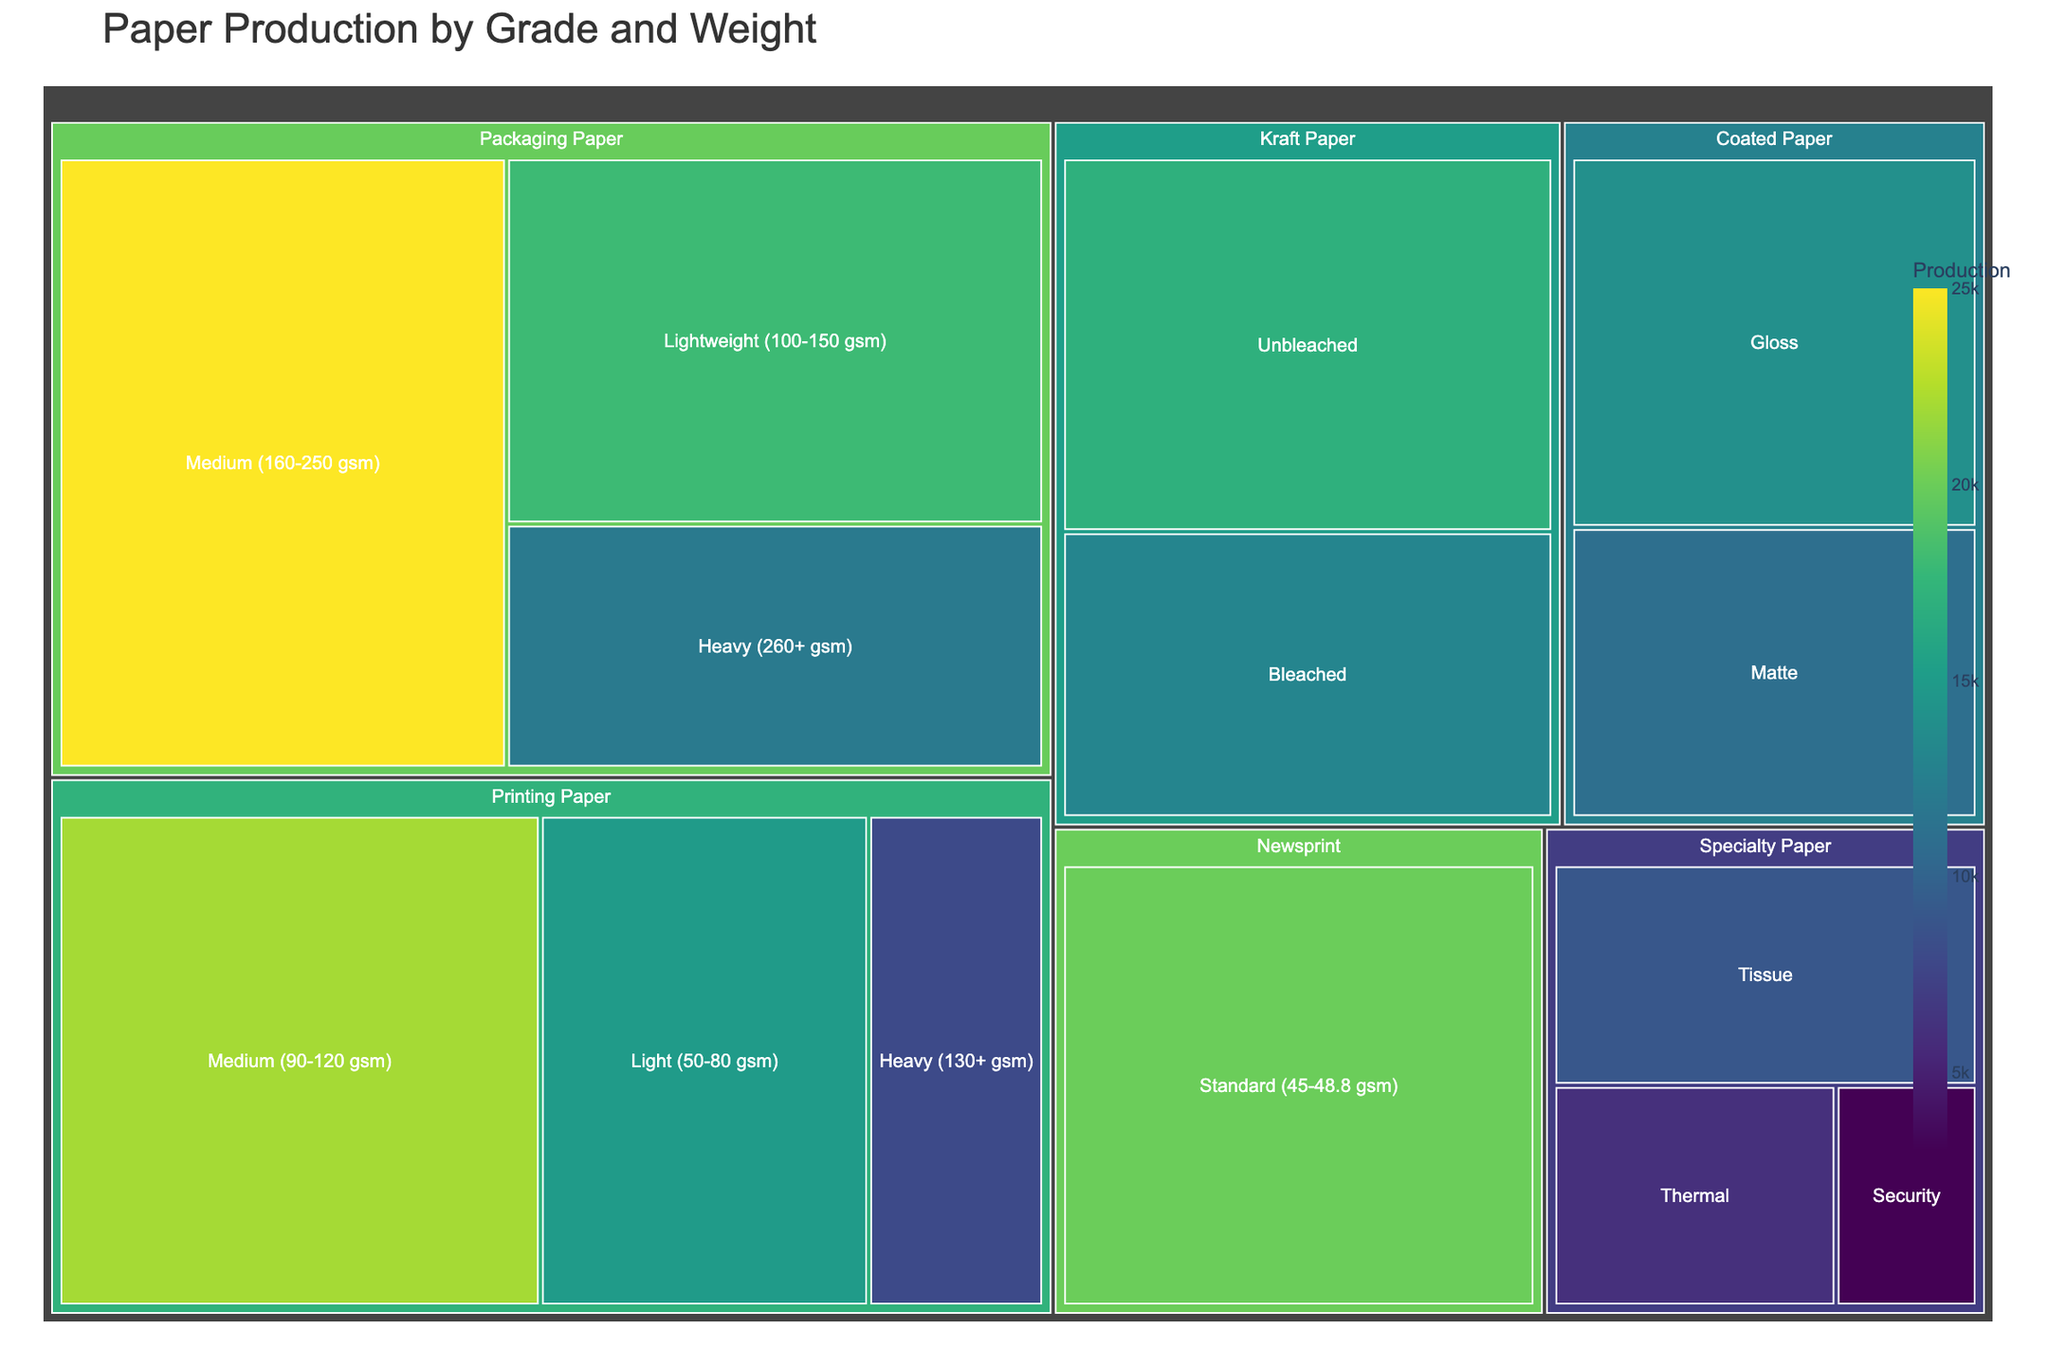What's the title of the treemap? The title is typically displayed at the top of the treemap. It provides an overview of what the treemap represents. In this case, the title reads "Paper Production by Grade and Weight".
Answer: Paper Production by Grade and Weight What is the highest production value, and which category does it belong to? To find the highest production value, one needs to compare all the production values listed in the treemap. The highest value is 25,000, and it is under the category 'Packaging Paper - Medium (160-250 gsm)'.
Answer: 25,000, Packaging Paper - Medium (160-250 gsm) Which category has the lightest weight range for Printing Paper, and what is its production value? The weight ranges for Printing Paper are Light (50-80 gsm), Medium (90-120 gsm), and Heavy (130+ gsm). The lightest range is Light (50-80 gsm) and its production value is mentioned as 15,000.
Answer: Light (50-80 gsm), 15,000 Compare the production values of Gloss Coated Paper and Matte Coated Paper. Which one is higher? To compare, look at the production values for both types under Coated Paper. Gloss has a production value of 14,000, and Matte has 11,000. Hence, Gloss Coated Paper has the higher production value.
Answer: Gloss Coated Paper What is the combined production value of all Kraft Paper categories? Add up the production values for the Kraft Paper categories. Unbleached is 17,000 and Bleached is 13,000. The combined value is 17,000 + 13,000 = 30,000.
Answer: 30,000 How does the production of Standard Newsprint compare to Medium Packaging Paper? Standard Newsprint has a production value of 20,000 while Medium Packaging Paper is 25,000. Hence, Medium Packaging Paper has a higher production value.
Answer: Medium Packaging Paper What's the difference in production between Light Packaging Paper and Heavy Packaging Paper? Light Packaging Paper has a production value of 18,000, and Heavy Packaging Paper has 12,000. The difference is 18,000 - 12,000 = 6,000.
Answer: 6,000 Which Specialty Paper category has the lowest production, and what is its value? Within Specialty Paper, the categories are Tissue, Security, and Thermal. The lowest production value is in the Security category with 3,000.
Answer: Security, 3,000 What's the total production value for all categories of Specialty Paper? Add up the production values from the Specialty Paper categories: Tissue (9,000), Security (3,000), and Thermal (6,000). The total is 9,000 + 3,000 + 6,000 = 18,000.
Answer: 18,000 Which weight category in Printing Paper has the highest production value? For Printing Paper, the categories are Light (50-80 gsm), Medium (90-120 gsm), and Heavy (130+ gsm). The highest production value is in the Medium weight category with 22,000.
Answer: Medium (90-120 gsm) 